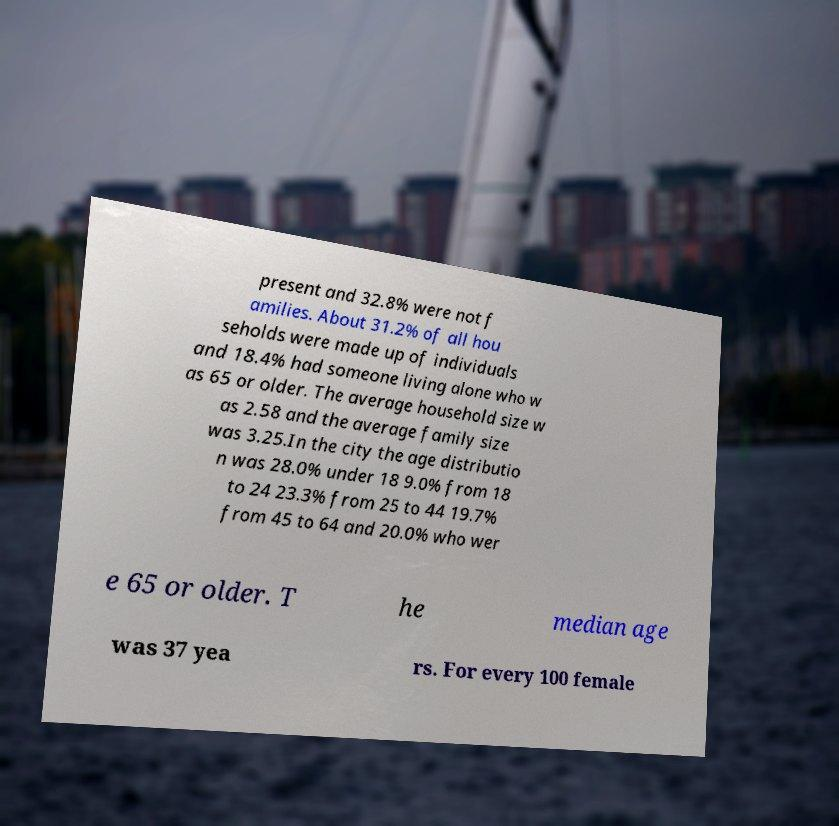There's text embedded in this image that I need extracted. Can you transcribe it verbatim? present and 32.8% were not f amilies. About 31.2% of all hou seholds were made up of individuals and 18.4% had someone living alone who w as 65 or older. The average household size w as 2.58 and the average family size was 3.25.In the city the age distributio n was 28.0% under 18 9.0% from 18 to 24 23.3% from 25 to 44 19.7% from 45 to 64 and 20.0% who wer e 65 or older. T he median age was 37 yea rs. For every 100 female 